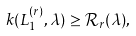<formula> <loc_0><loc_0><loc_500><loc_500>k ( L _ { 1 } ^ { ( r ) } , \lambda ) \geq { \mathcal { R } } _ { r } ( \lambda ) ,</formula> 